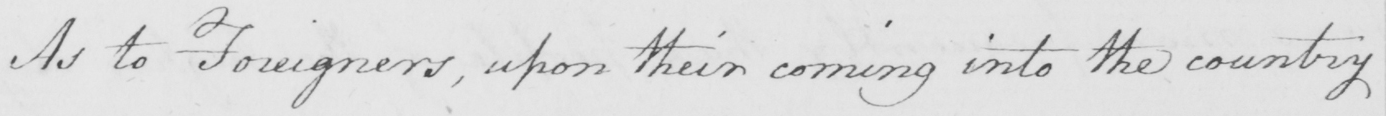What text is written in this handwritten line? As to foreigners, upon their coming into the country 